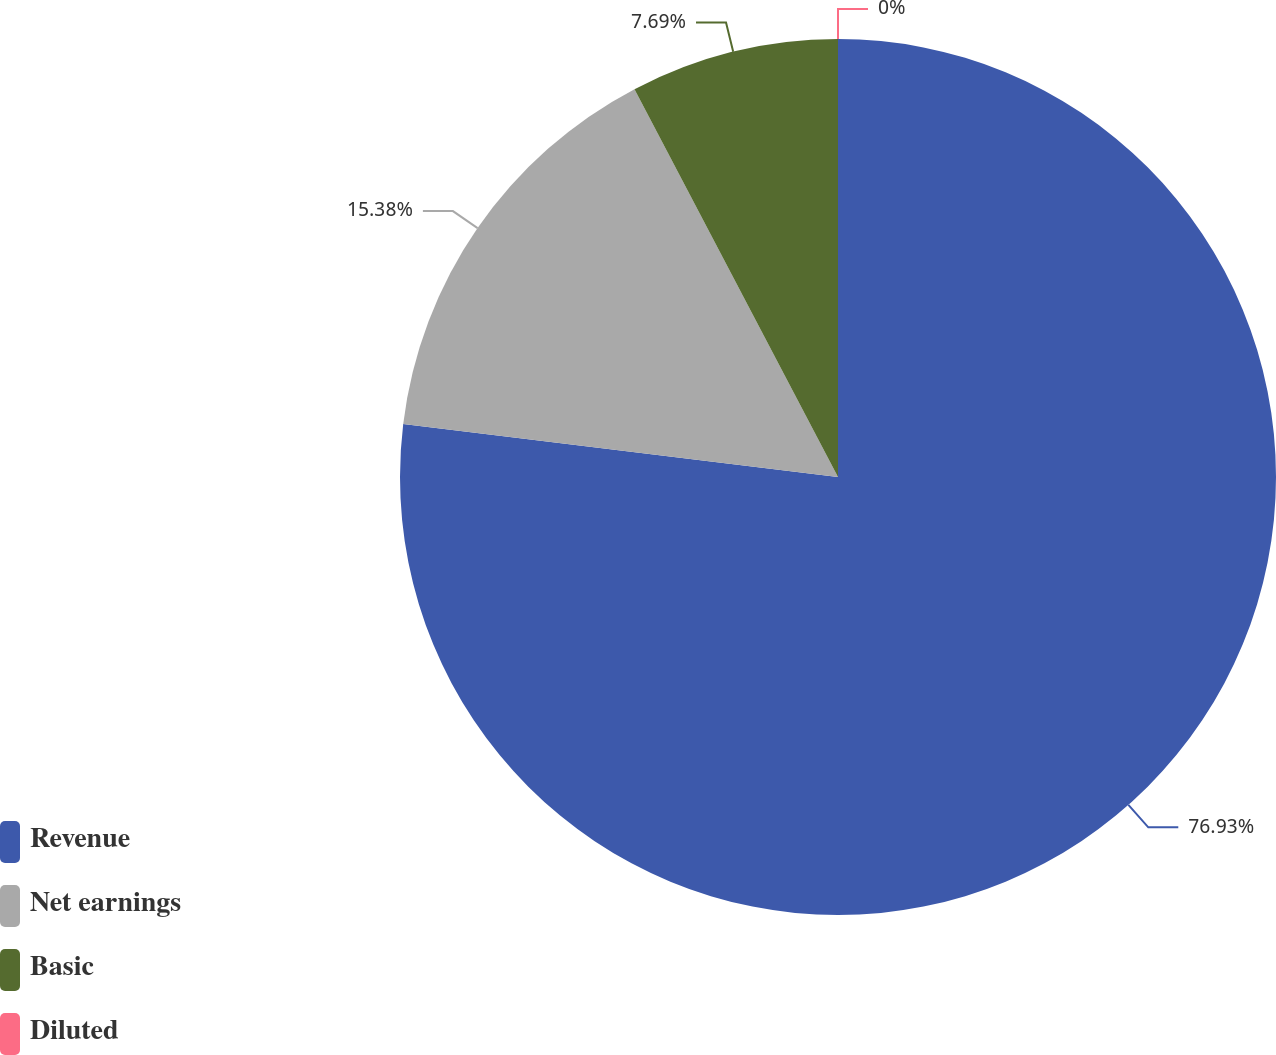Convert chart to OTSL. <chart><loc_0><loc_0><loc_500><loc_500><pie_chart><fcel>Revenue<fcel>Net earnings<fcel>Basic<fcel>Diluted<nl><fcel>76.92%<fcel>15.38%<fcel>7.69%<fcel>0.0%<nl></chart> 